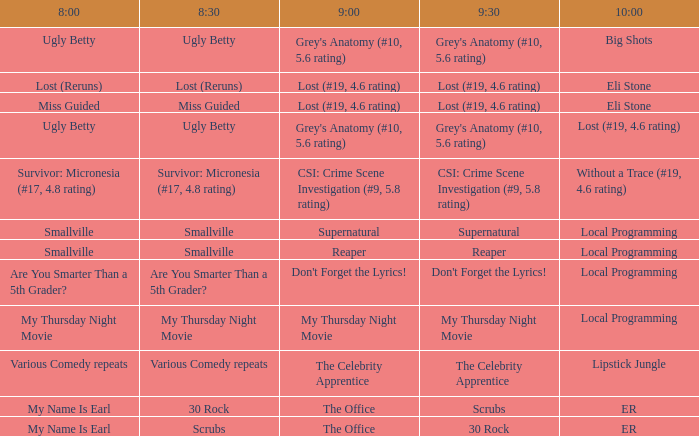What occurs at 9:30 when at 8:30 it is scrubbing? 30 Rock. 